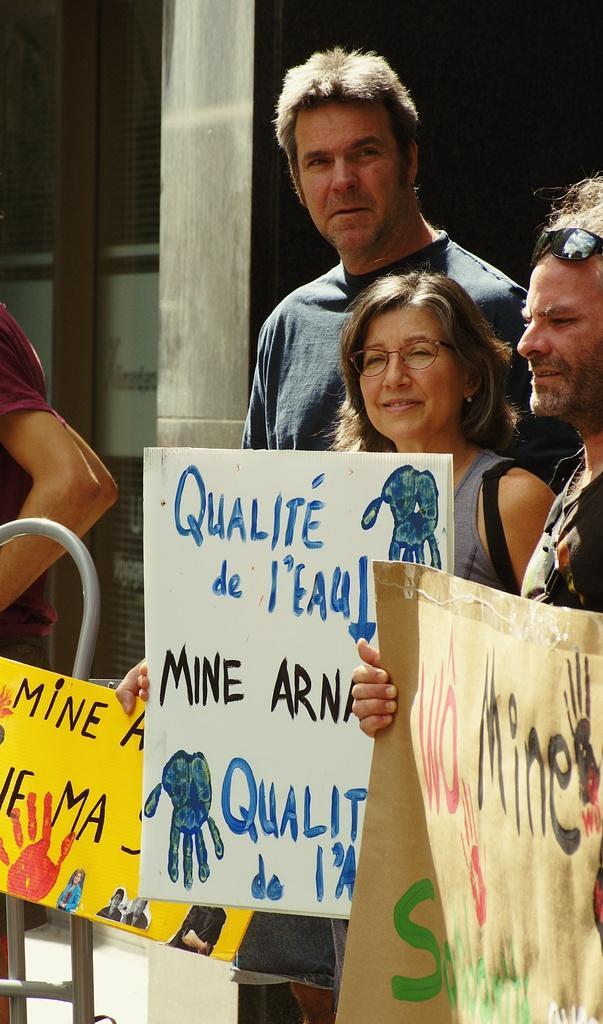In one or two sentences, can you explain what this image depicts? In this picture we can see four people were three are holding posters with their hands, spectacle, goggles and in the background we can see a pillar, windows. 